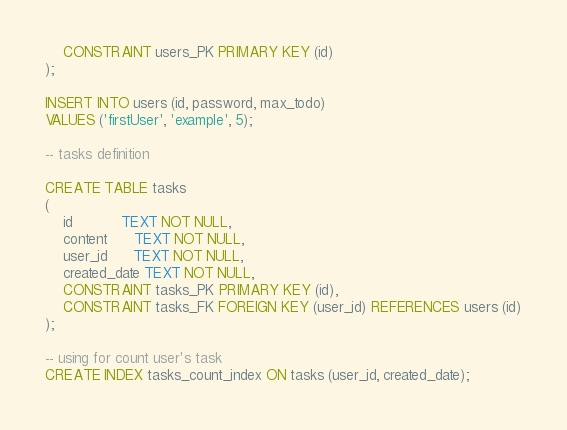Convert code to text. <code><loc_0><loc_0><loc_500><loc_500><_SQL_>    CONSTRAINT users_PK PRIMARY KEY (id)
);

INSERT INTO users (id, password, max_todo)
VALUES ('firstUser', 'example', 5);

-- tasks definition

CREATE TABLE tasks
(
    id           TEXT NOT NULL,
    content      TEXT NOT NULL,
    user_id      TEXT NOT NULL,
    created_date TEXT NOT NULL,
    CONSTRAINT tasks_PK PRIMARY KEY (id),
    CONSTRAINT tasks_FK FOREIGN KEY (user_id) REFERENCES users (id)
);

-- using for count user's task
CREATE INDEX tasks_count_index ON tasks (user_id, created_date);
</code> 